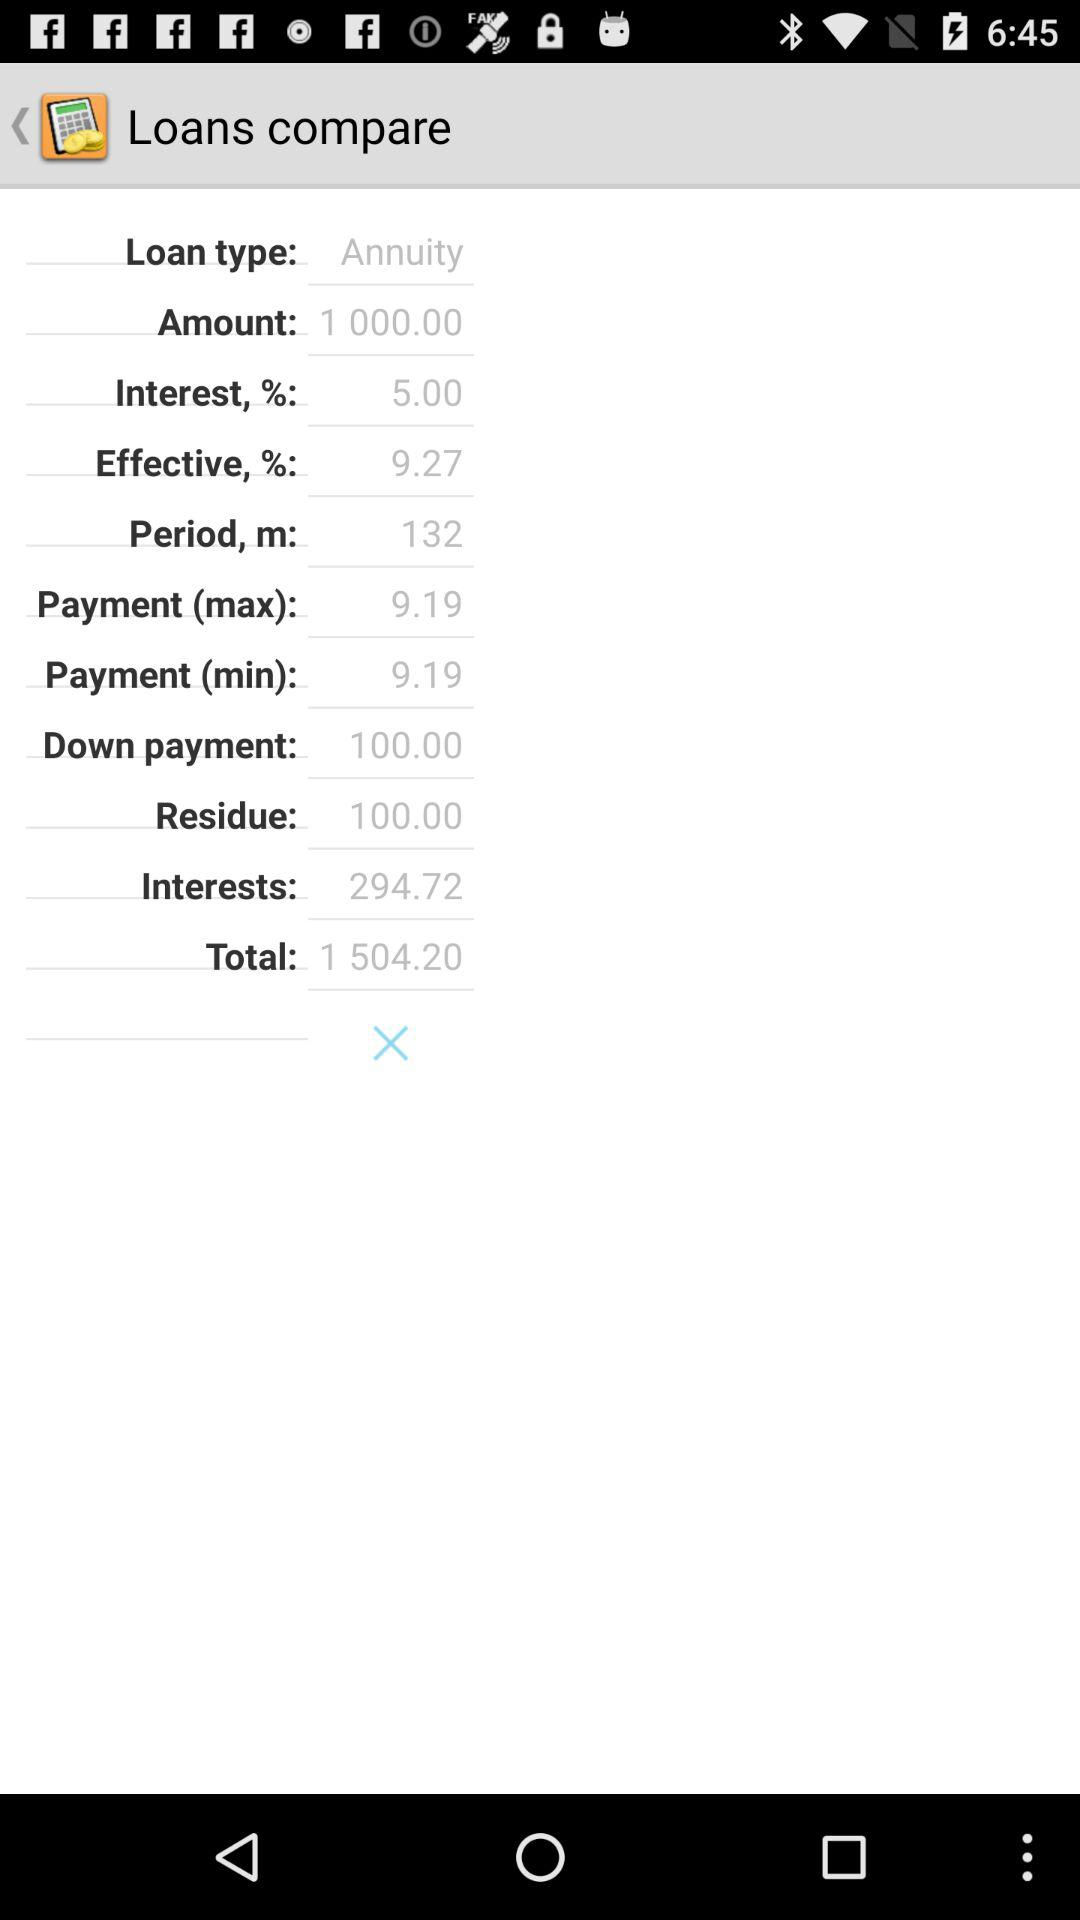What is the total amount? The total amount is 1504.20. 